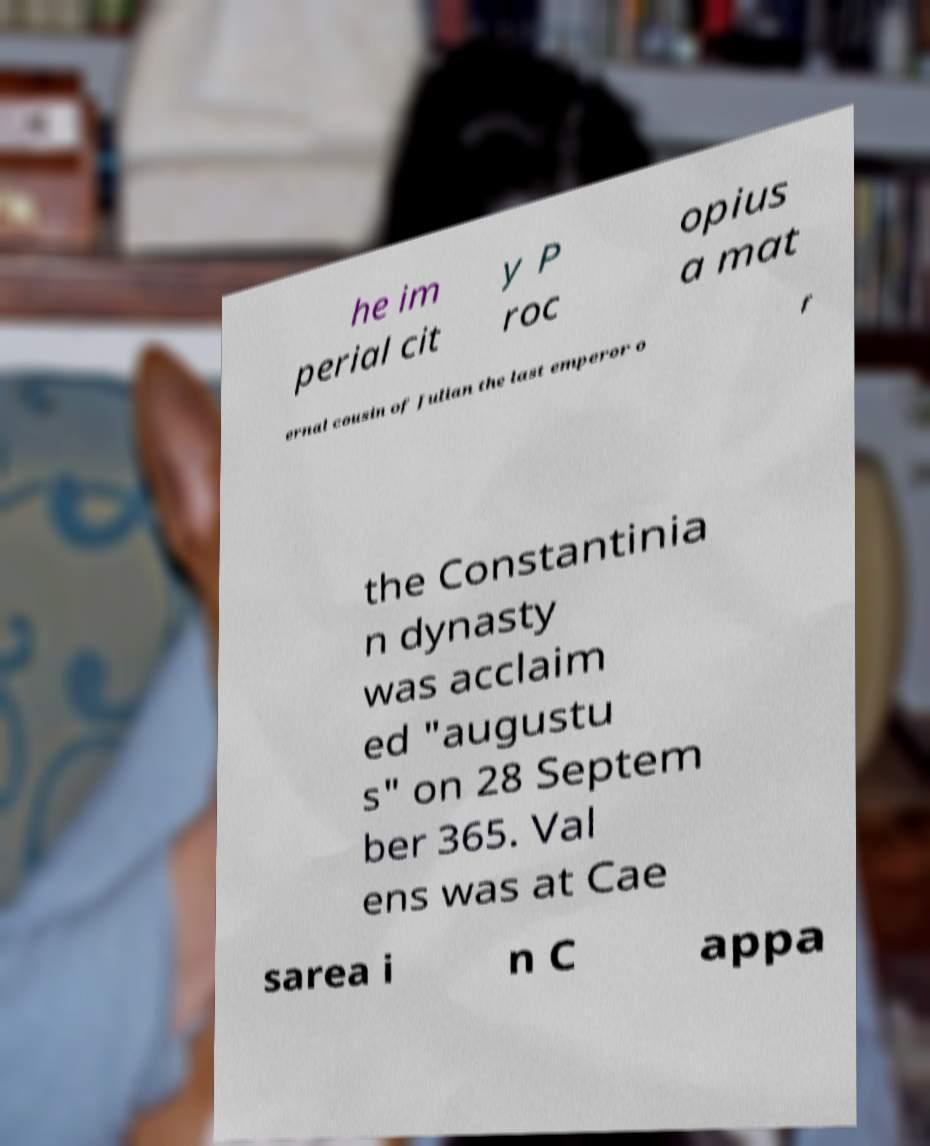Can you read and provide the text displayed in the image?This photo seems to have some interesting text. Can you extract and type it out for me? he im perial cit y P roc opius a mat ernal cousin of Julian the last emperor o f the Constantinia n dynasty was acclaim ed "augustu s" on 28 Septem ber 365. Val ens was at Cae sarea i n C appa 